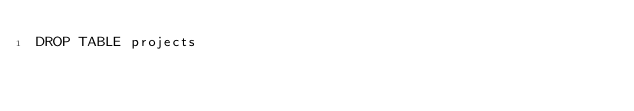Convert code to text. <code><loc_0><loc_0><loc_500><loc_500><_SQL_>DROP TABLE projects
</code> 